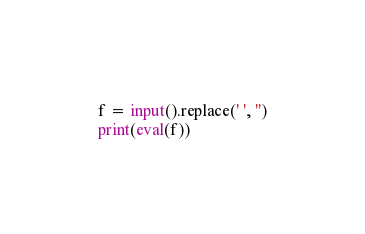<code> <loc_0><loc_0><loc_500><loc_500><_Python_>f = input().replace(' ', '')
print(eval(f))</code> 